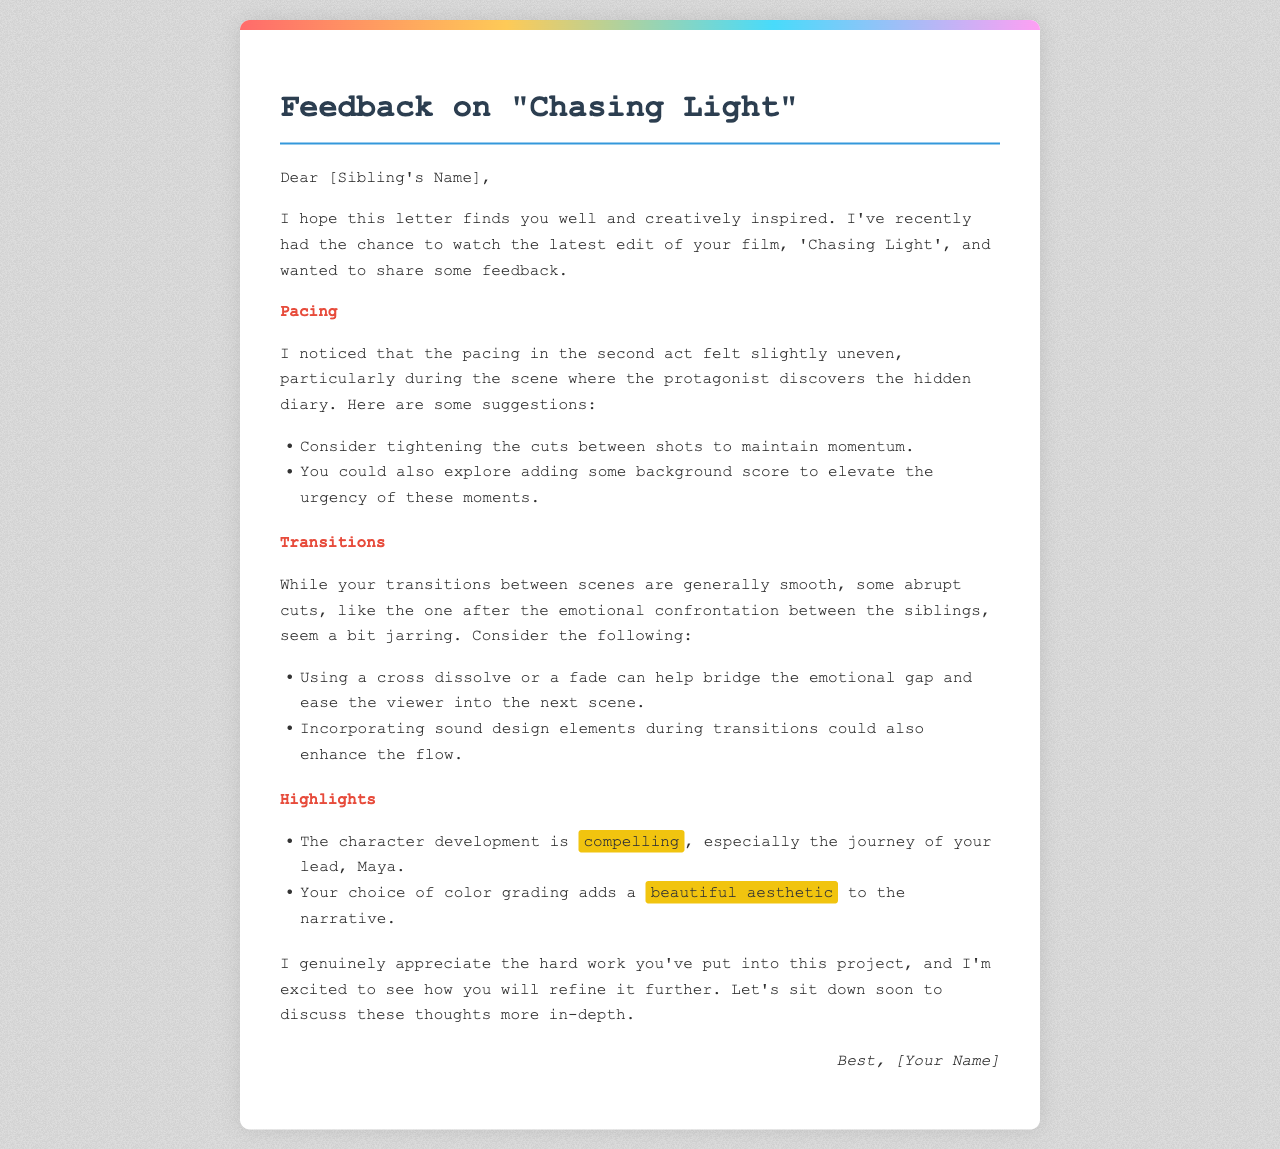what is the title of the film? The title of the film mentioned in the document is 'Chasing Light'.
Answer: 'Chasing Light' who is the protagonist in the film? The protagonist mentioned in the document is Maya.
Answer: Maya what specific act felt uneven in pacing? The second act is described as feeling slightly uneven in pacing.
Answer: second act what transition is suggested to ease the viewer into the next scene? A cross dissolve or a fade is suggested to bridge the emotional gap.
Answer: cross dissolve or a fade what visual element adds a beautiful aesthetic to the narrative? The color grading is noted to enhance the aesthetic of the narrative.
Answer: color grading what is a suggested addition to elevate the urgency in the scene with the diary? Adding background score is suggested to elevate the urgency.
Answer: background score who is the letter addressed to? The letter is addressed to [Sibling's Name].
Answer: [Sibling's Name] what is the closing sentiment of the letter? The closing sentiment expresses appreciation for the sibling's hard work.
Answer: appreciation for the hard work 